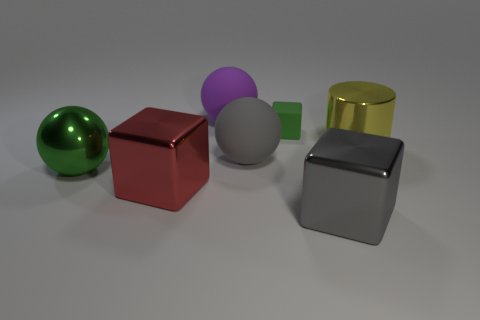Is there any other thing that is the same material as the big cylinder?
Provide a succinct answer. Yes. The tiny thing on the right side of the rubber sphere that is in front of the rubber sphere that is behind the cylinder is made of what material?
Keep it short and to the point. Rubber. Is the big yellow thing the same shape as the tiny green rubber object?
Offer a very short reply. No. There is a big purple thing that is the same shape as the green metal object; what is it made of?
Offer a very short reply. Rubber. What number of large rubber things have the same color as the small rubber thing?
Your answer should be compact. 0. What size is the green object that is the same material as the purple object?
Ensure brevity in your answer.  Small. How many red things are metal balls or rubber spheres?
Keep it short and to the point. 0. There is a big metallic thing to the left of the red metal thing; what number of purple matte objects are to the left of it?
Offer a very short reply. 0. Is the number of rubber spheres in front of the gray shiny cube greater than the number of green shiny balls that are in front of the large red block?
Your answer should be very brief. No. What material is the small green block?
Provide a succinct answer. Rubber. 